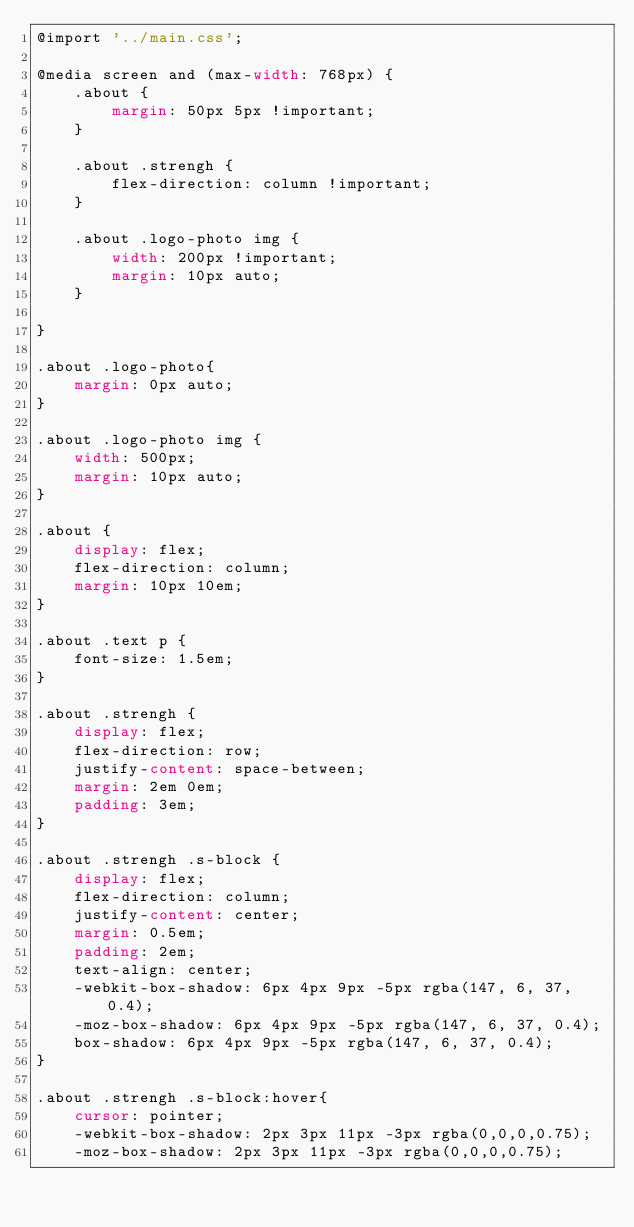<code> <loc_0><loc_0><loc_500><loc_500><_CSS_>@import '../main.css';

@media screen and (max-width: 768px) {
    .about {
        margin: 50px 5px !important;
    }

    .about .strengh {
        flex-direction: column !important;
    }

    .about .logo-photo img {
        width: 200px !important;
        margin: 10px auto;
    }

}

.about .logo-photo{
    margin: 0px auto;
}

.about .logo-photo img {
    width: 500px;
    margin: 10px auto;
}

.about {
    display: flex;
    flex-direction: column;
    margin: 10px 10em;
}

.about .text p {
    font-size: 1.5em;
}

.about .strengh {
    display: flex;
    flex-direction: row;
    justify-content: space-between;
    margin: 2em 0em;
    padding: 3em;
}

.about .strengh .s-block {
    display: flex;
    flex-direction: column;
    justify-content: center;
    margin: 0.5em;
    padding: 2em;
    text-align: center;
    -webkit-box-shadow: 6px 4px 9px -5px rgba(147, 6, 37, 0.4);
    -moz-box-shadow: 6px 4px 9px -5px rgba(147, 6, 37, 0.4);
    box-shadow: 6px 4px 9px -5px rgba(147, 6, 37, 0.4);
}

.about .strengh .s-block:hover{
    cursor: pointer;
    -webkit-box-shadow: 2px 3px 11px -3px rgba(0,0,0,0.75);
    -moz-box-shadow: 2px 3px 11px -3px rgba(0,0,0,0.75);</code> 